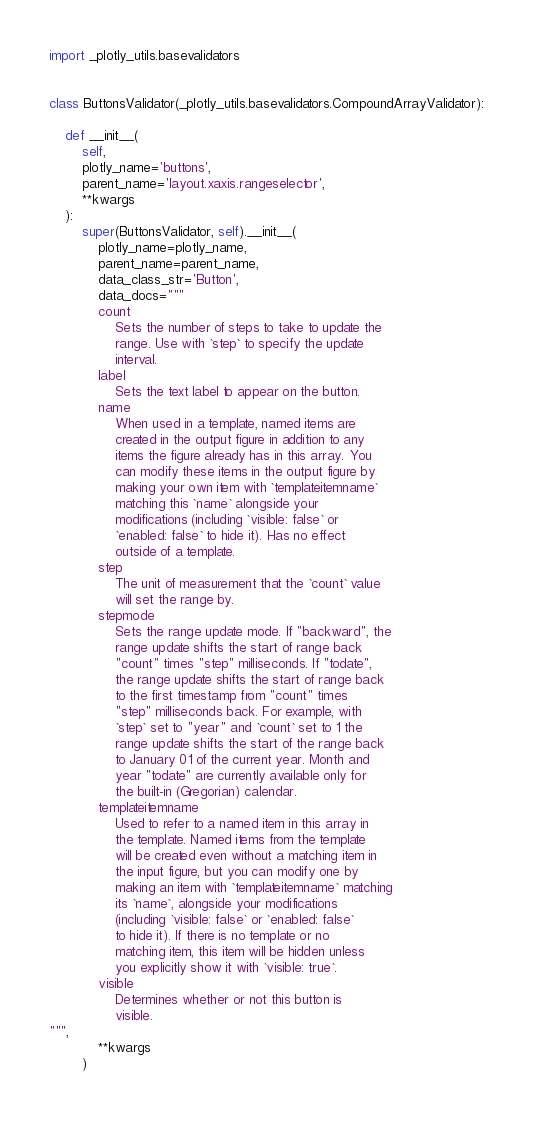Convert code to text. <code><loc_0><loc_0><loc_500><loc_500><_Python_>import _plotly_utils.basevalidators


class ButtonsValidator(_plotly_utils.basevalidators.CompoundArrayValidator):

    def __init__(
        self,
        plotly_name='buttons',
        parent_name='layout.xaxis.rangeselector',
        **kwargs
    ):
        super(ButtonsValidator, self).__init__(
            plotly_name=plotly_name,
            parent_name=parent_name,
            data_class_str='Button',
            data_docs="""
            count
                Sets the number of steps to take to update the
                range. Use with `step` to specify the update
                interval.
            label
                Sets the text label to appear on the button.
            name
                When used in a template, named items are
                created in the output figure in addition to any
                items the figure already has in this array. You
                can modify these items in the output figure by
                making your own item with `templateitemname`
                matching this `name` alongside your
                modifications (including `visible: false` or
                `enabled: false` to hide it). Has no effect
                outside of a template.
            step
                The unit of measurement that the `count` value
                will set the range by.
            stepmode
                Sets the range update mode. If "backward", the
                range update shifts the start of range back
                "count" times "step" milliseconds. If "todate",
                the range update shifts the start of range back
                to the first timestamp from "count" times
                "step" milliseconds back. For example, with
                `step` set to "year" and `count` set to 1 the
                range update shifts the start of the range back
                to January 01 of the current year. Month and
                year "todate" are currently available only for
                the built-in (Gregorian) calendar.
            templateitemname
                Used to refer to a named item in this array in
                the template. Named items from the template
                will be created even without a matching item in
                the input figure, but you can modify one by
                making an item with `templateitemname` matching
                its `name`, alongside your modifications
                (including `visible: false` or `enabled: false`
                to hide it). If there is no template or no
                matching item, this item will be hidden unless
                you explicitly show it with `visible: true`.
            visible
                Determines whether or not this button is
                visible.
""",
            **kwargs
        )
</code> 